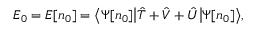Convert formula to latex. <formula><loc_0><loc_0><loc_500><loc_500>E _ { 0 } = E [ n _ { 0 } ] = { \left \langle } \Psi [ n _ { 0 } ] { \left | } { \hat { T } } + { \hat { V } } + { \hat { U } } { \right | } \Psi [ n _ { 0 } ] { \right \rangle } ,</formula> 